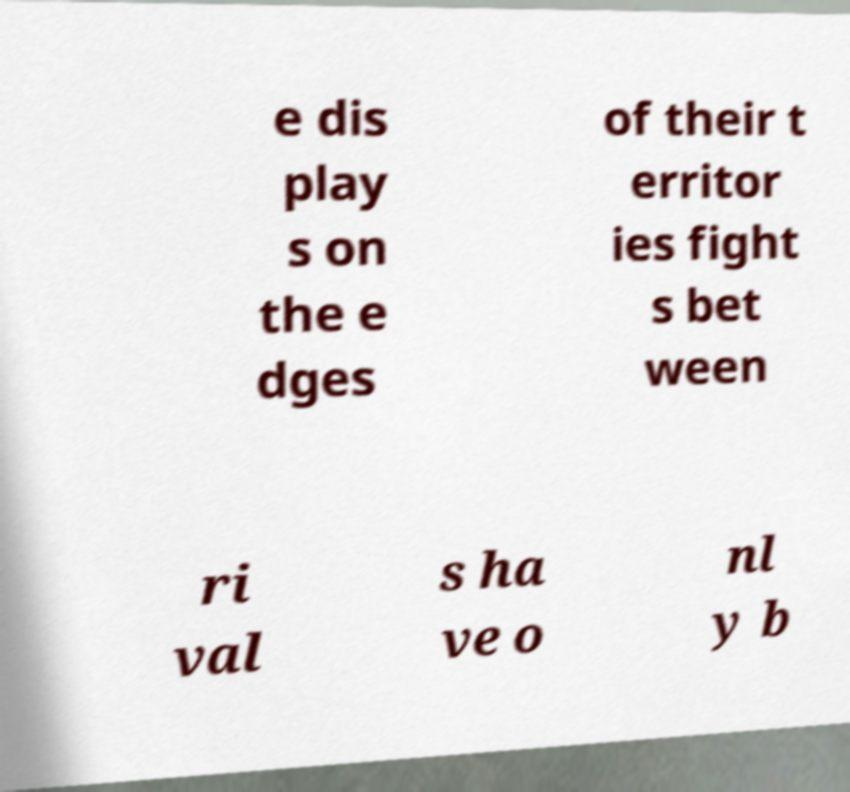Please read and relay the text visible in this image. What does it say? e dis play s on the e dges of their t erritor ies fight s bet ween ri val s ha ve o nl y b 